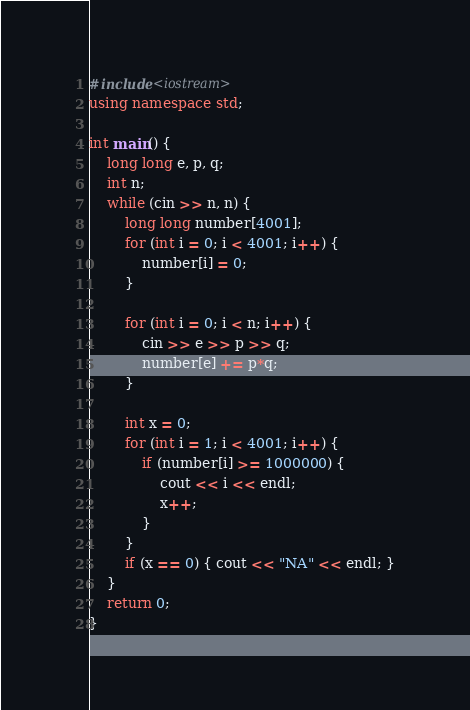<code> <loc_0><loc_0><loc_500><loc_500><_C++_>#include<iostream>
using namespace std;

int main() {
	long long e, p, q;
	int n;
	while (cin >> n, n) {
		long long number[4001];
		for (int i = 0; i < 4001; i++) {
			number[i] = 0;
		}

		for (int i = 0; i < n; i++) {
			cin >> e >> p >> q;
			number[e] += p*q;
		}

		int x = 0;
		for (int i = 1; i < 4001; i++) {
			if (number[i] >= 1000000) {
				cout << i << endl;
				x++;
			}
		}
		if (x == 0) { cout << "NA" << endl; }
	}
	return 0;
}</code> 